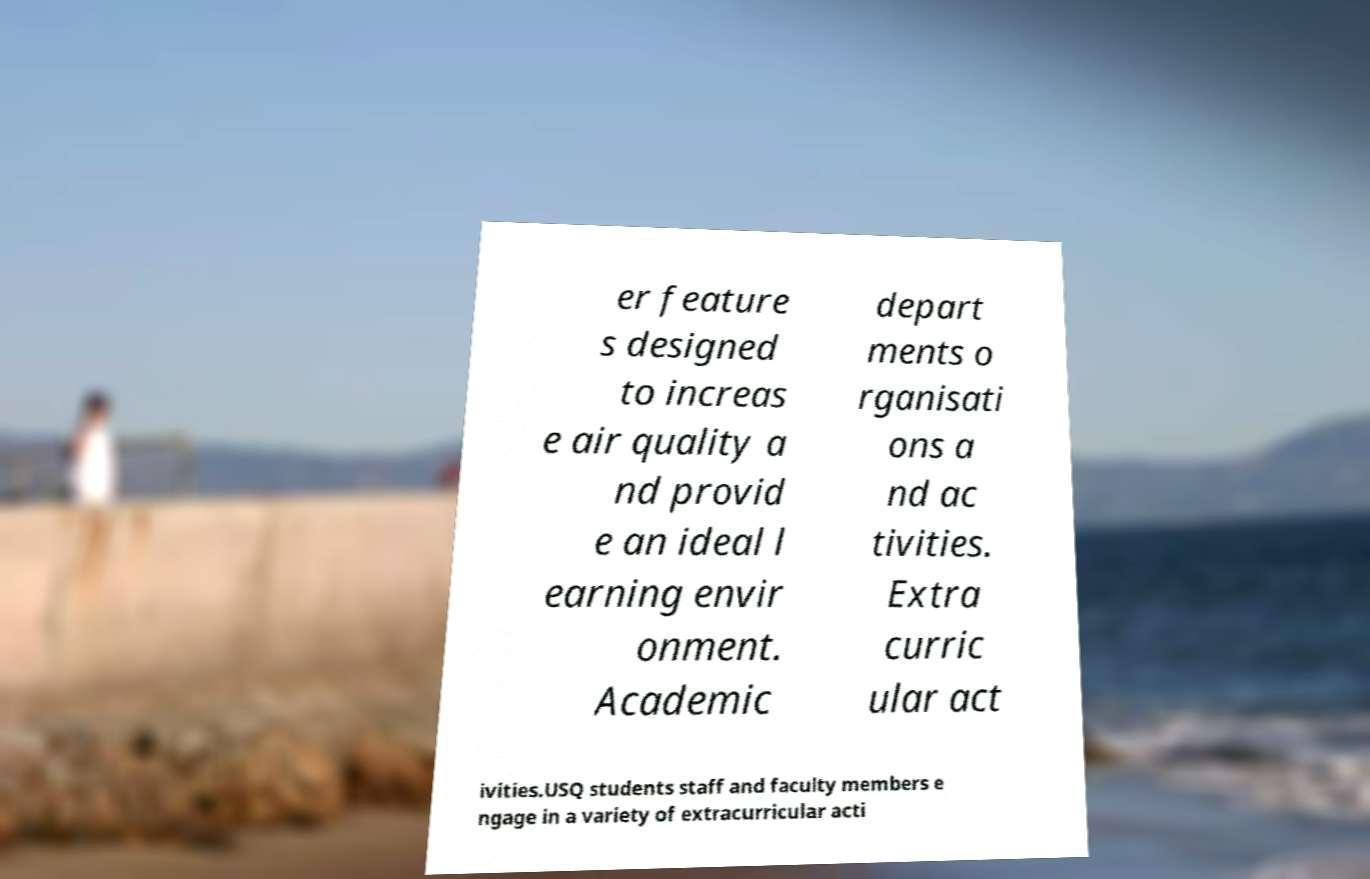I need the written content from this picture converted into text. Can you do that? er feature s designed to increas e air quality a nd provid e an ideal l earning envir onment. Academic depart ments o rganisati ons a nd ac tivities. Extra curric ular act ivities.USQ students staff and faculty members e ngage in a variety of extracurricular acti 